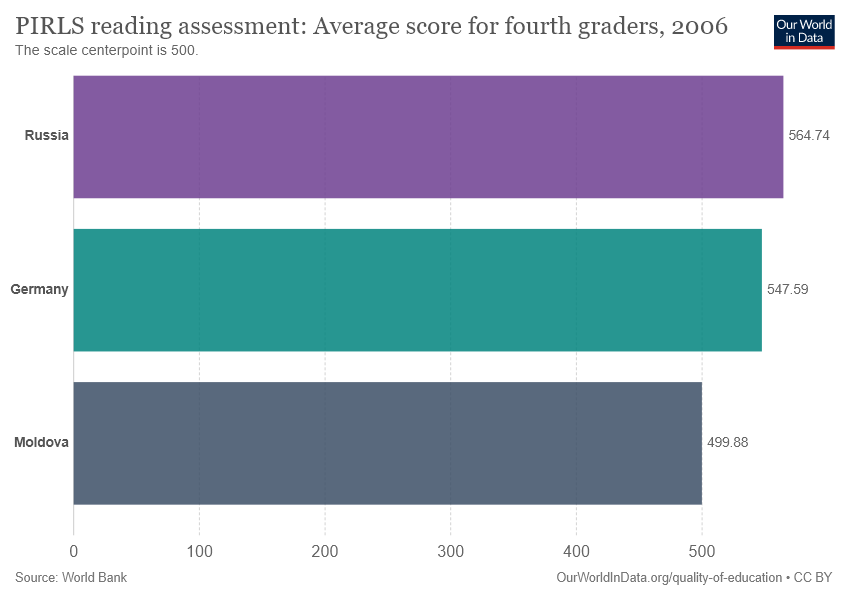Specify some key components in this picture. The PIRLS reading assessment value between Russia and Moldova is 64.86. Moldova has the lowest PIRLS reading assessment value among all countries. 